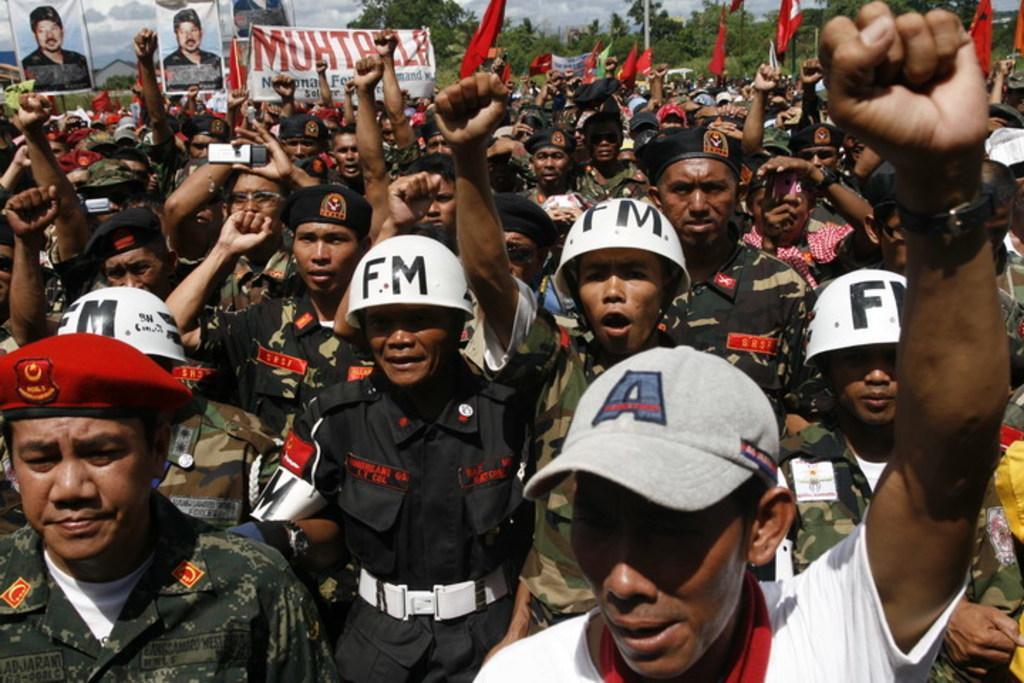Can you describe this image briefly? In the image there are many people standing with caps and helmets on their heads. They are holding banners and posters of a person in their hands. In the background there are trees. 